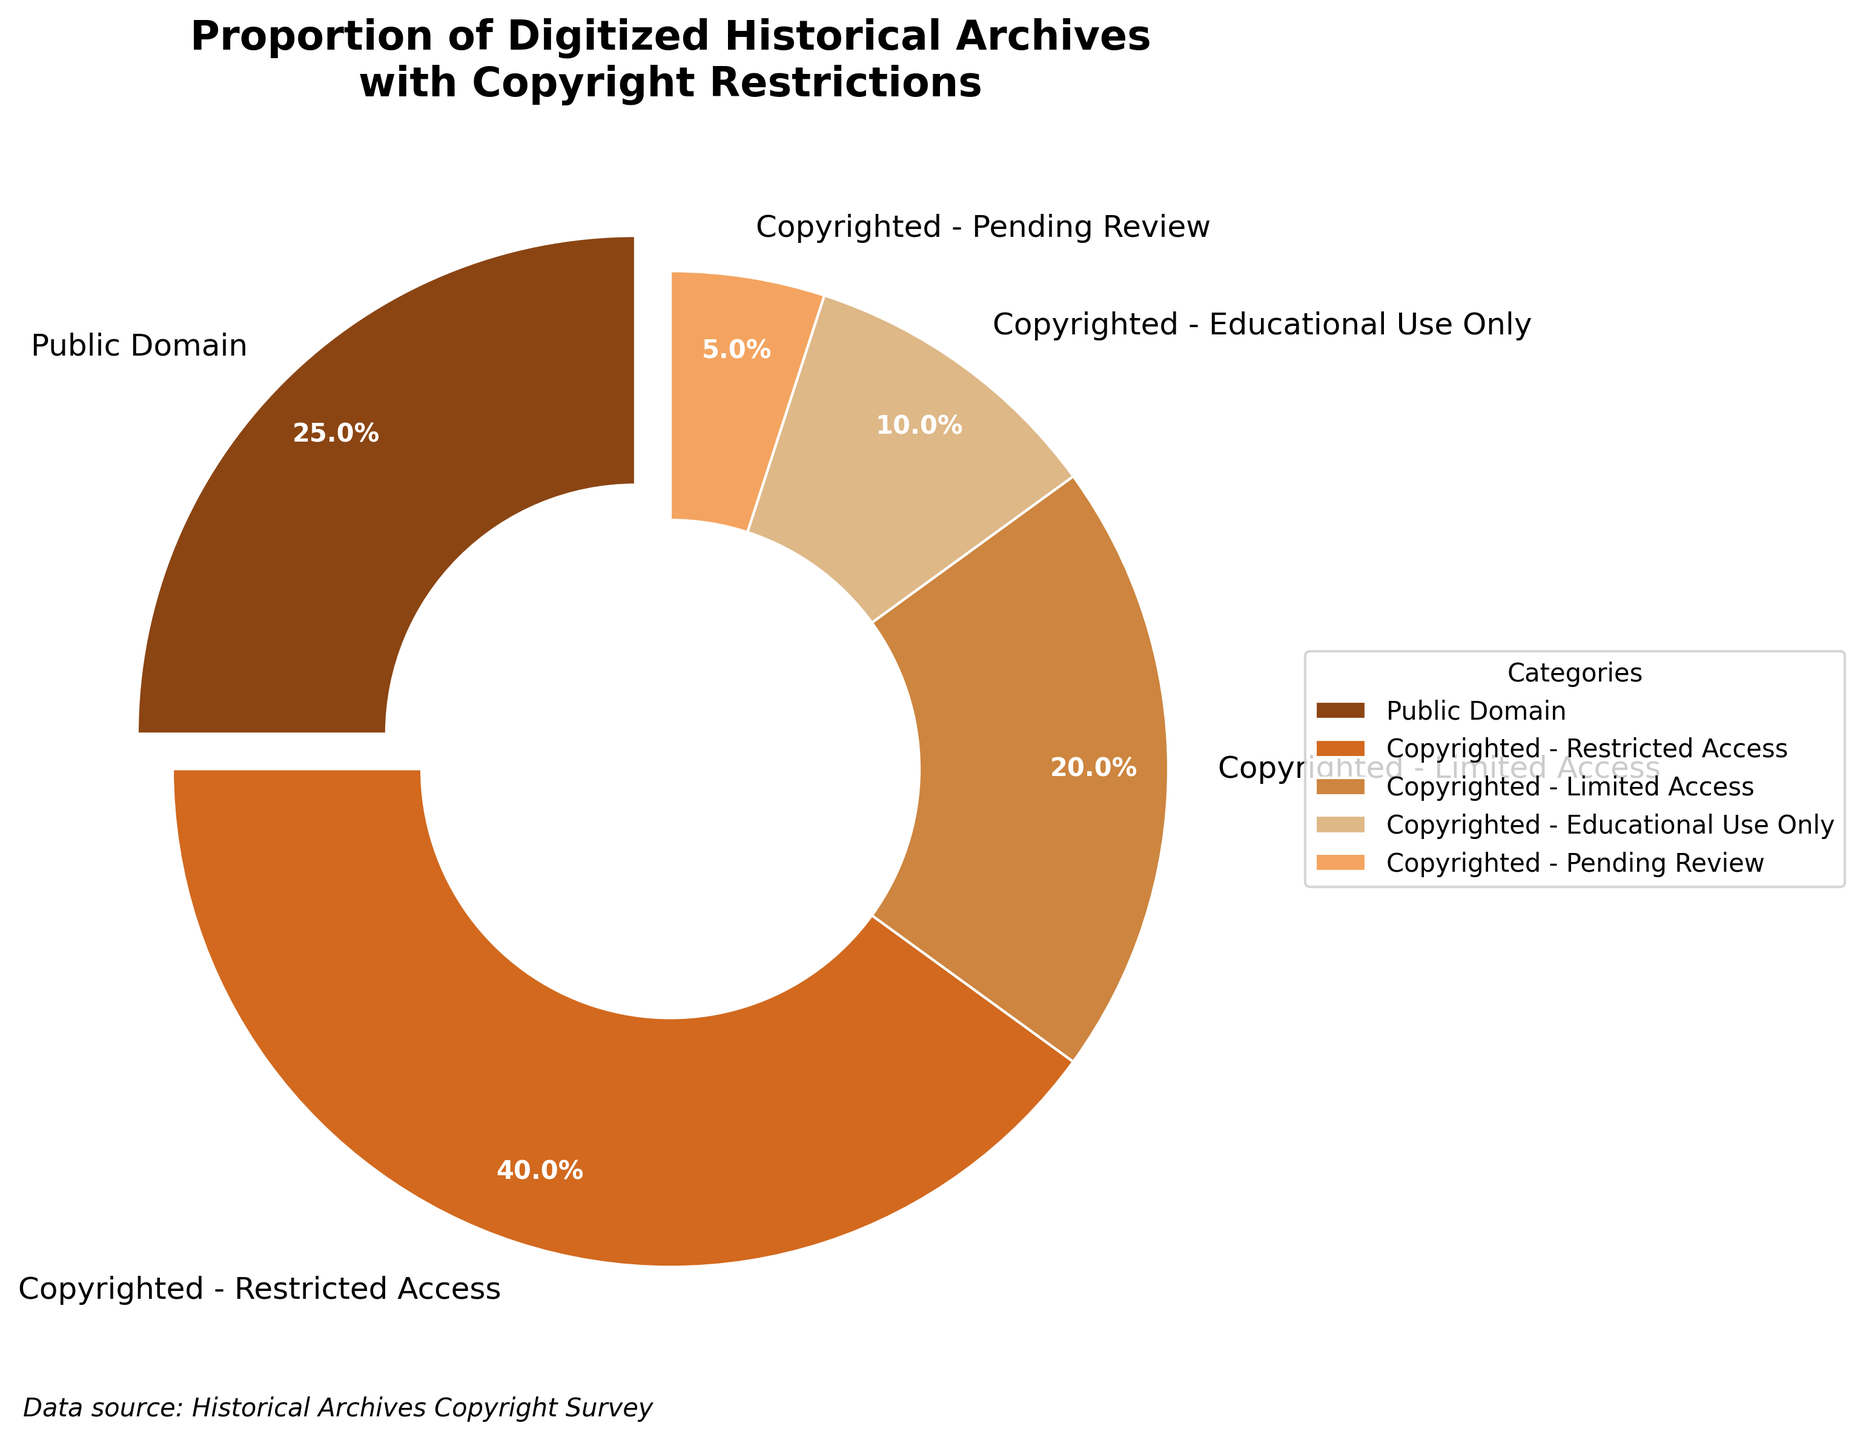What's the percentage of archives that are in the public domain? The slice of the pie chart labeled "Public Domain" states 25%.
Answer: 25% Which category occupies the largest portion of the pie chart? The largest slice of the pie chart is labeled "Copyrighted - Restricted Access," which shows 40%.
Answer: Copyrighted - Restricted Access How do the percentages of 'Copyrighted - Limited Access' and 'Copyrighted - Educational Use Only' compare? The slice labeled "Copyrighted - Limited Access" is 20%, while the slice labeled "Copyrighted - Educational Use Only" is 10%. Since 20% is greater than 10%, "Copyrighted - Limited Access" has the higher percentage.
Answer: Copyrighted - Limited Access has a higher percentage What is the total percentage of archives that are copyrighted but not in restricted access? Adding the percentages of 'Copyrighted - Limited Access' (20%), 'Copyrighted - Educational Use Only' (10%), and 'Copyrighted - Pending Review' (5%) results in 20% + 10% + 5% = 35%.
Answer: 35% Which category occupies the smallest portion of the pie chart? The smallest slice of the pie chart is labeled "Copyrighted - Pending Review" and shows 5%.
Answer: Copyrighted - Pending Review If you combine the percentages of 'Public Domain' and 'Copyrighted - Pending Review', what is the total? Adding the percentages of 'Public Domain' (25%) and 'Copyrighted - Pending Review' (5%) results in 25% + 5% = 30%.
Answer: 30% What is the color of the slice representing 'Copyrighted - Educational Use Only'? The slice corresponding to 'Copyrighted - Educational Use Only' is visually shown in a shade of light brown/tan.
Answer: Light brown/tan What is the difference in percentage between 'Copyrighted - Restricted Access' and 'Public Domain'? The percentage for 'Copyrighted - Restricted Access' is 40%, and the percentage for 'Public Domain' is 25%. So, the difference is 40% - 25% = 15%.
Answer: 15% What portion of the archives is not publicly accessible? The non-public categories include 'Copyrighted - Restricted Access' (40%), 'Copyrighted - Limited Access' (20%), 'Copyrighted - Educational Use Only' (10%), and 'Copyrighted - Pending Review' (5%). Summing these gives 40% + 20% + 10% + 5% = 75%.
Answer: 75% 